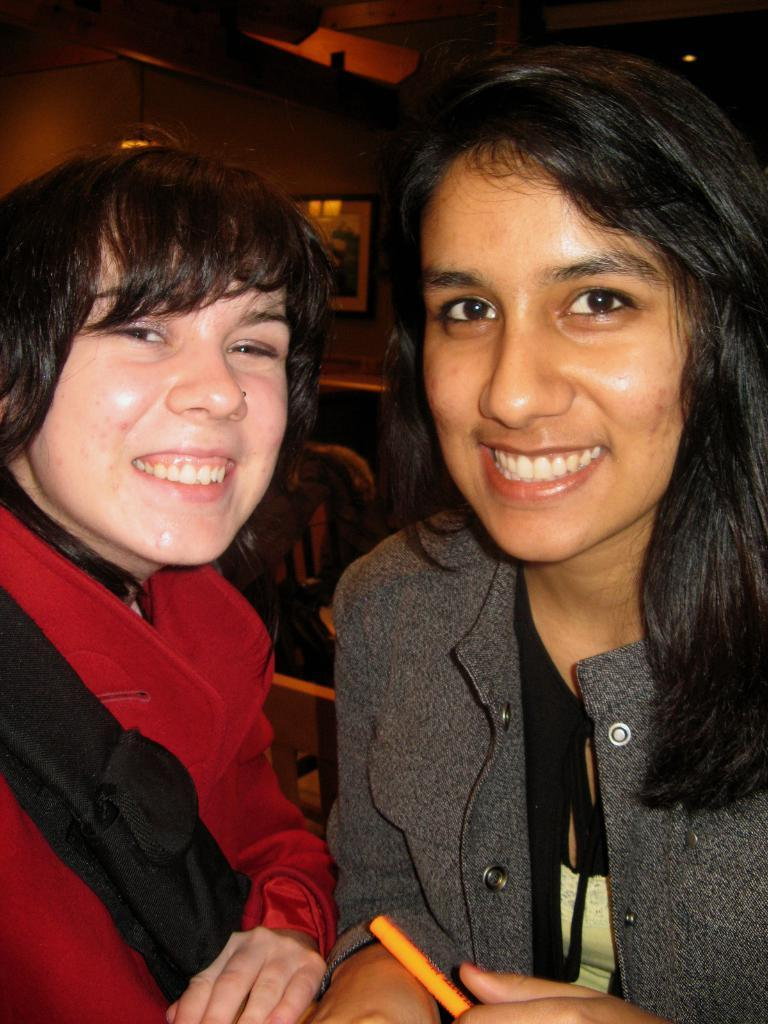How many people are in the image? There are two people in the image. What is the facial expression of the people in the image? The people are smiling. What can be seen in the background of the image? There is a wall, a photo frame, and some objects in the background of the image. What type of honey can be seen dripping from the kittens in the image? There are no kittens or honey present in the image. How does the concept of friction relate to the people in the image? The concept of friction does not relate to the people in the image, as it is a physical property and not relevant to the scene depicted. 